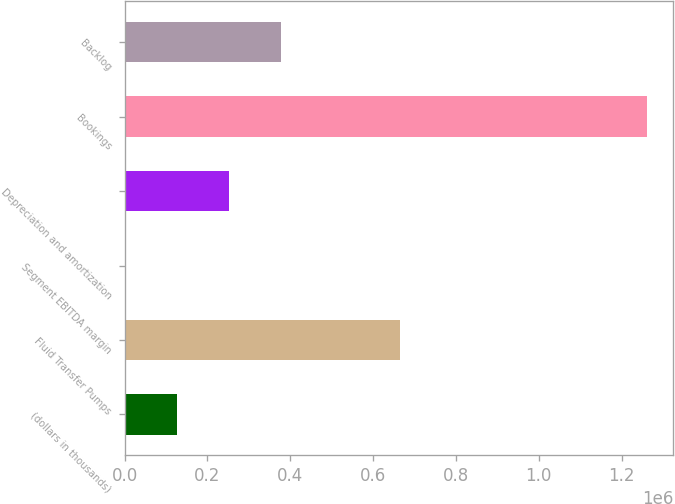<chart> <loc_0><loc_0><loc_500><loc_500><bar_chart><fcel>(dollars in thousands)<fcel>Fluid Transfer Pumps<fcel>Segment EBITDA margin<fcel>Depreciation and amortization<fcel>Bookings<fcel>Backlog<nl><fcel>126212<fcel>665559<fcel>22.1<fcel>252402<fcel>1.26192e+06<fcel>378592<nl></chart> 